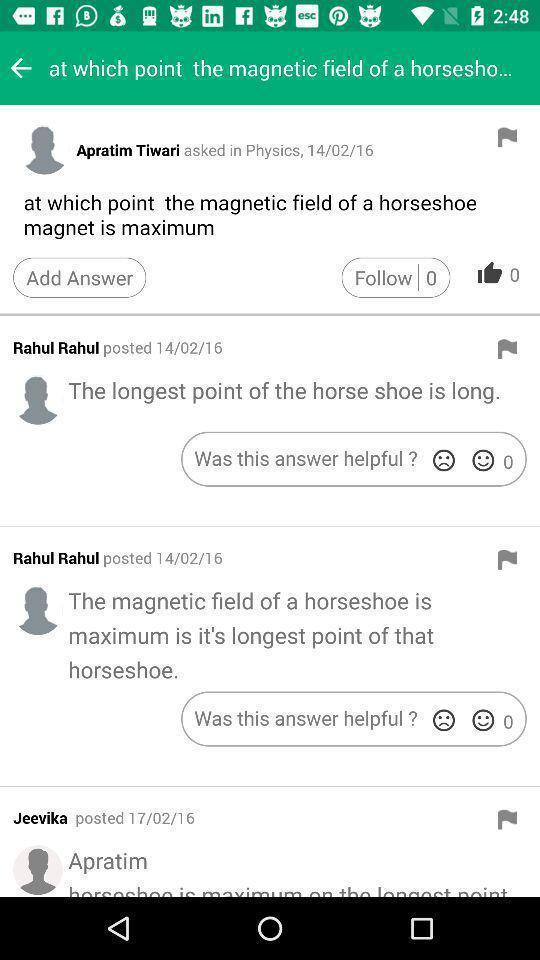Please provide a description for this image. Some questions and answers in the application regarding horseshoe. 